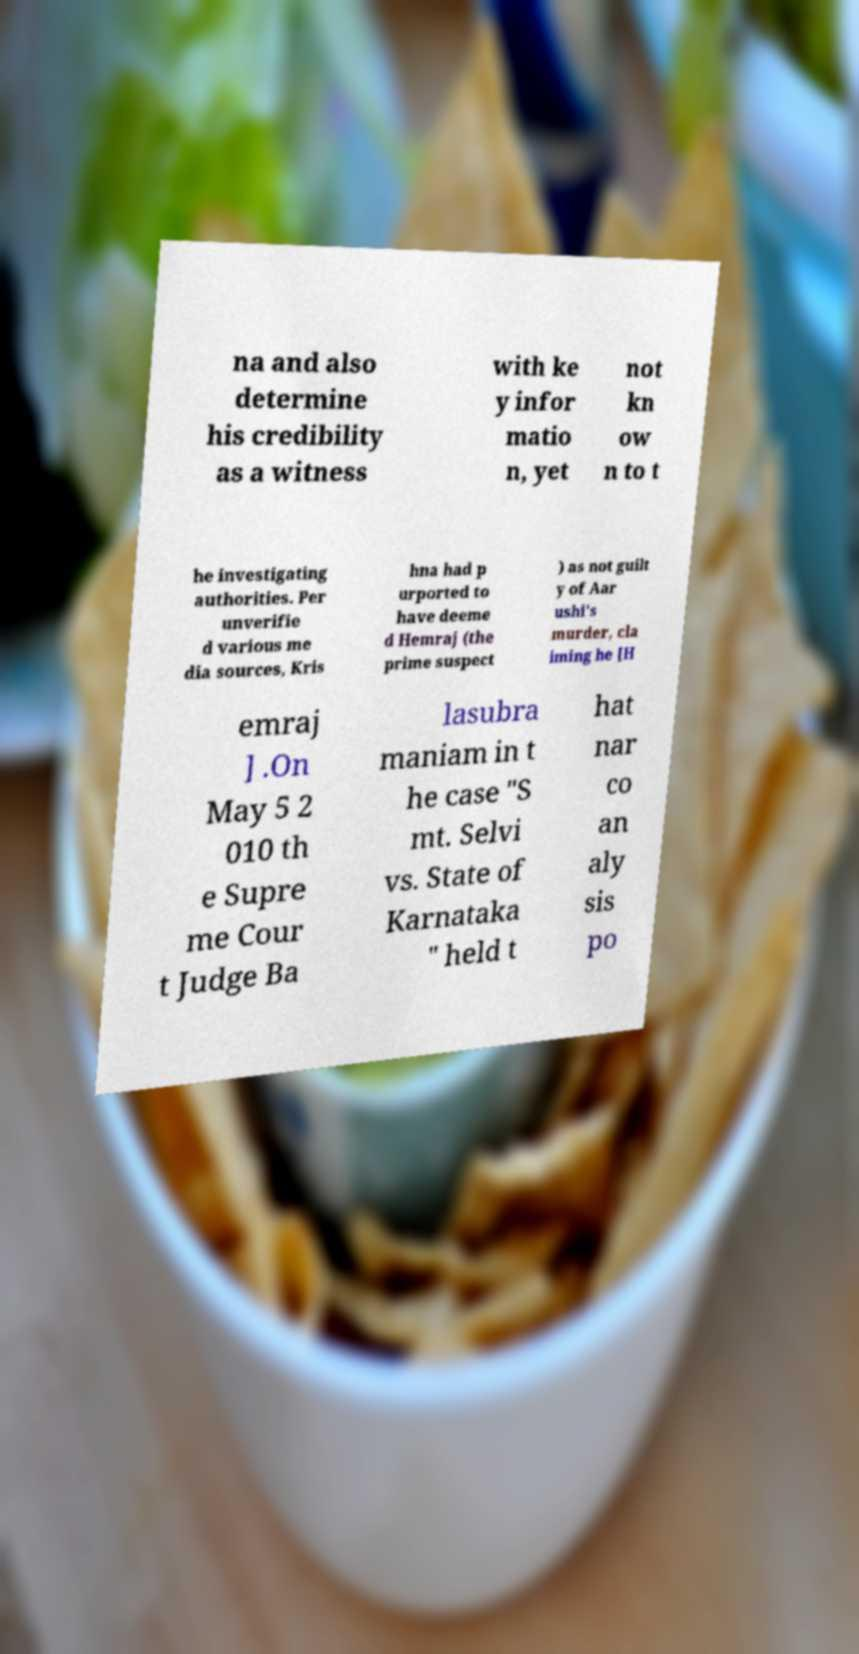Can you read and provide the text displayed in the image?This photo seems to have some interesting text. Can you extract and type it out for me? na and also determine his credibility as a witness with ke y infor matio n, yet not kn ow n to t he investigating authorities. Per unverifie d various me dia sources, Kris hna had p urported to have deeme d Hemraj (the prime suspect ) as not guilt y of Aar ushi's murder, cla iming he [H emraj ] .On May 5 2 010 th e Supre me Cour t Judge Ba lasubra maniam in t he case "S mt. Selvi vs. State of Karnataka " held t hat nar co an aly sis po 